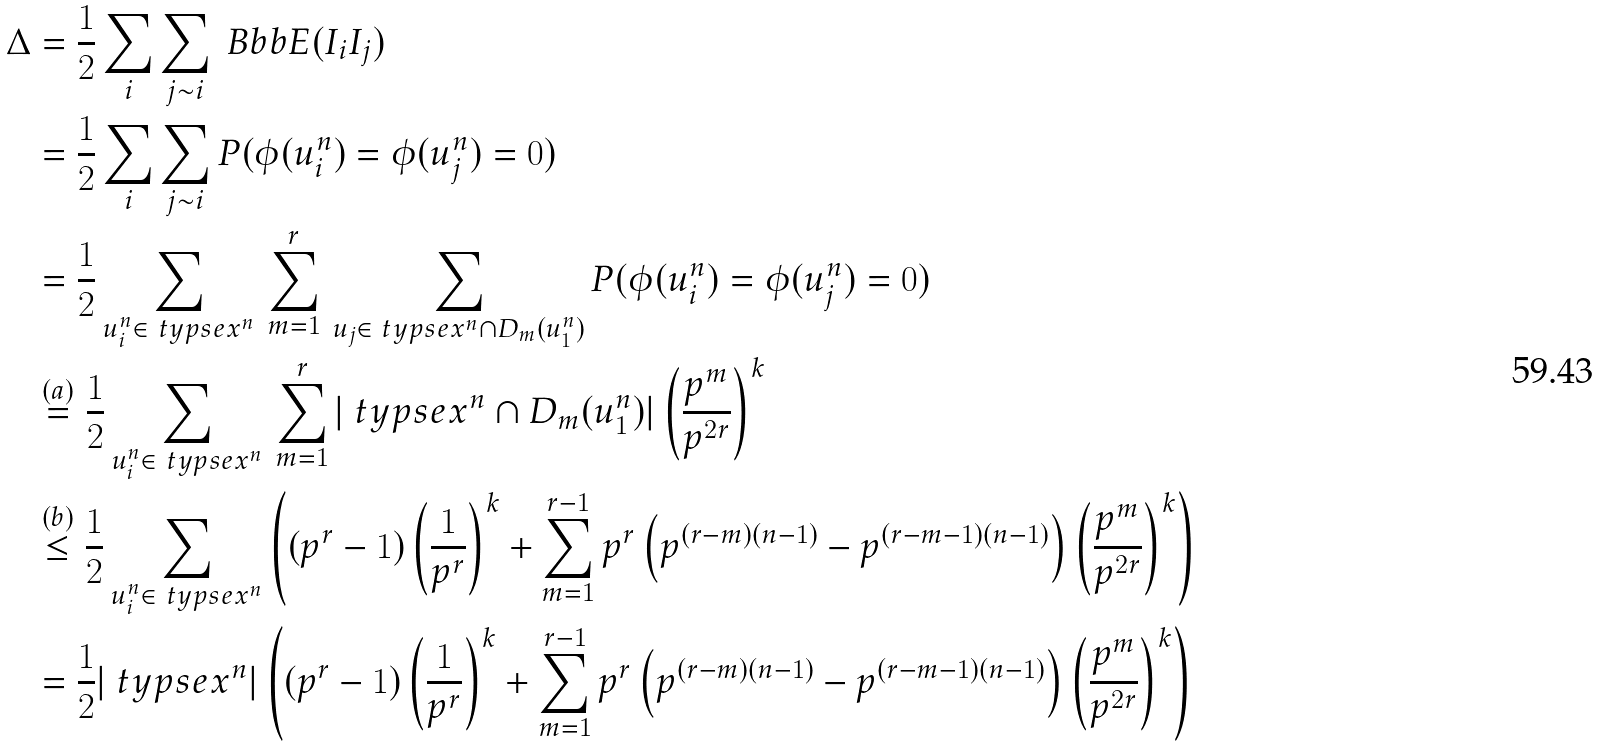<formula> <loc_0><loc_0><loc_500><loc_500>\Delta & = \frac { 1 } { 2 } \sum _ { i } \sum _ { j \sim i } \ B b b { E } ( I _ { i } I _ { j } ) \\ & = \frac { 1 } { 2 } \sum _ { i } \sum _ { j \sim i } P ( \phi ( u _ { i } ^ { n } ) = \phi ( u _ { j } ^ { n } ) = 0 ) \\ & = \frac { 1 } { 2 } \sum _ { u _ { i } ^ { n } \in \ t y p s e { x ^ { n } } } \, \sum _ { m = 1 } ^ { r } \, \sum _ { u _ { j } \in \ t y p s e { x ^ { n } } \cap D _ { m } ( u _ { 1 } ^ { n } ) } P ( \phi ( u _ { i } ^ { n } ) = \phi ( u _ { j } ^ { n } ) = 0 ) \\ & \stackrel { ( a ) } { = } \frac { 1 } { 2 } \sum _ { u _ { i } ^ { n } \in \ t y p s e { x ^ { n } } } \, \sum _ { m = 1 } ^ { r } | \ t y p s e { x ^ { n } } \cap D _ { m } ( u _ { 1 } ^ { n } ) | \left ( \frac { p ^ { m } } { p ^ { 2 r } } \right ) ^ { k } \\ & \stackrel { ( b ) } { \leq } \frac { 1 } { 2 } \sum _ { u _ { i } ^ { n } \in \ t y p s e { x ^ { n } } } \left ( ( p ^ { r } - 1 ) \left ( \frac { 1 } { p ^ { r } } \right ) ^ { k } + \sum _ { m = 1 } ^ { r - 1 } p ^ { r } \left ( p ^ { ( r - m ) ( n - 1 ) } - p ^ { ( r - m - 1 ) ( n - 1 ) } \right ) \left ( \frac { p ^ { m } } { p ^ { 2 r } } \right ) ^ { k } \right ) \\ & = \frac { 1 } { 2 } | \ t y p s e { x ^ { n } } | \left ( ( p ^ { r } - 1 ) \left ( \frac { 1 } { p ^ { r } } \right ) ^ { k } + \sum _ { m = 1 } ^ { r - 1 } p ^ { r } \left ( p ^ { ( r - m ) ( n - 1 ) } - p ^ { ( r - m - 1 ) ( n - 1 ) } \right ) \left ( \frac { p ^ { m } } { p ^ { 2 r } } \right ) ^ { k } \right )</formula> 